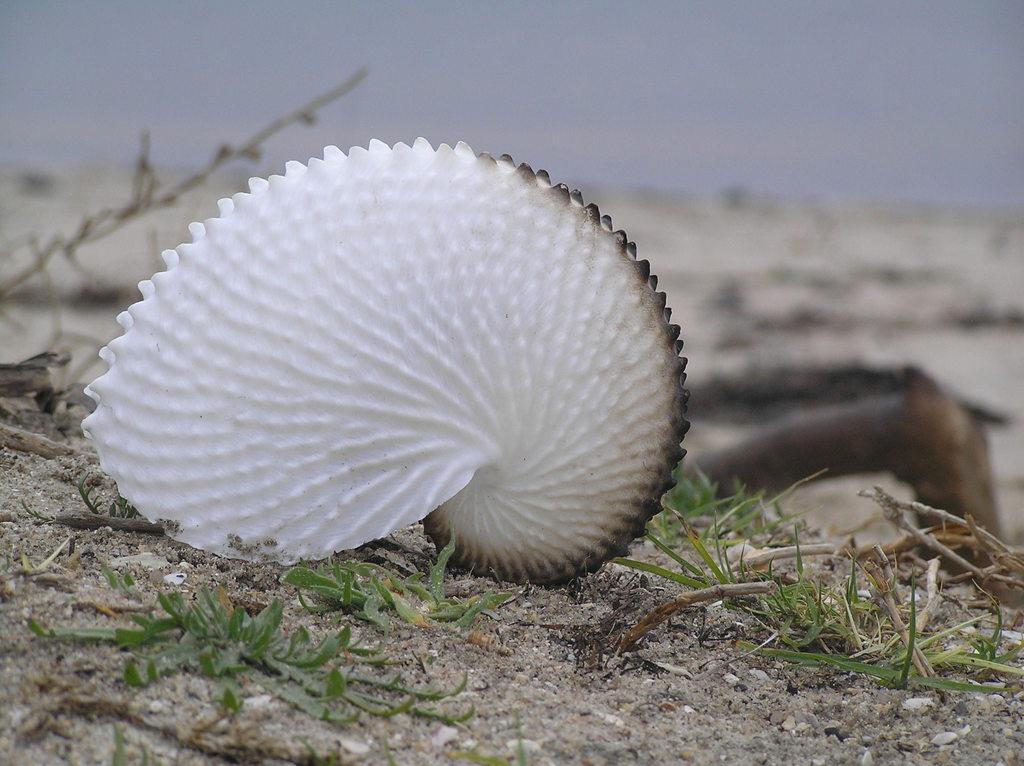In one or two sentences, can you explain what this image depicts? In the image we can see there is a sea shell kept on the ground and there are leaves of the plant on the ground. Behind the image is blurred. 